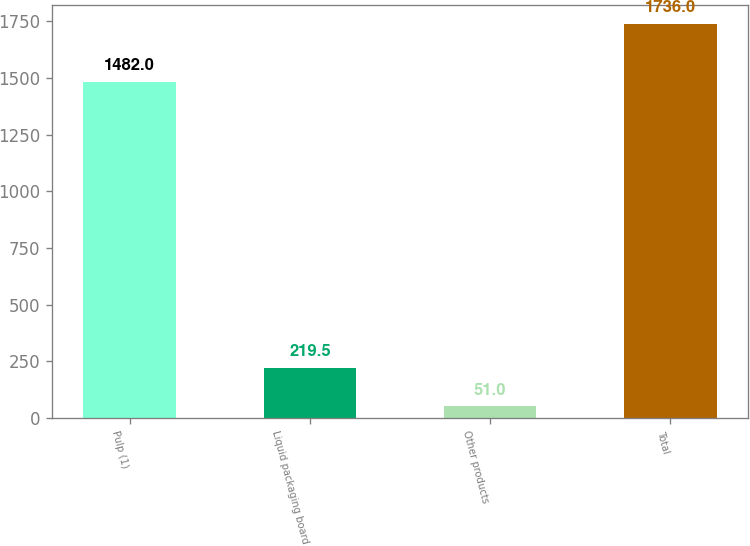Convert chart to OTSL. <chart><loc_0><loc_0><loc_500><loc_500><bar_chart><fcel>Pulp (1)<fcel>Liquid packaging board<fcel>Other products<fcel>Total<nl><fcel>1482<fcel>219.5<fcel>51<fcel>1736<nl></chart> 